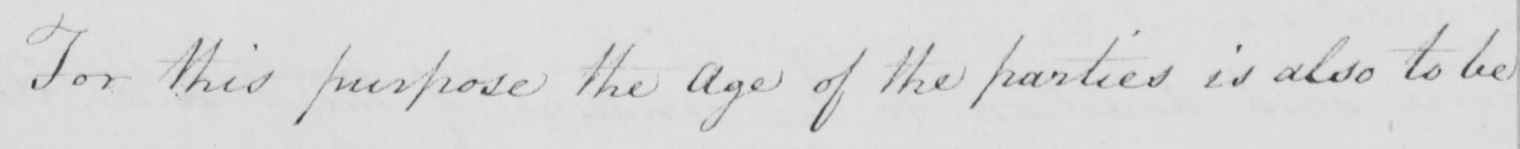What is written in this line of handwriting? For this purpose the Age of the parties is also to be 